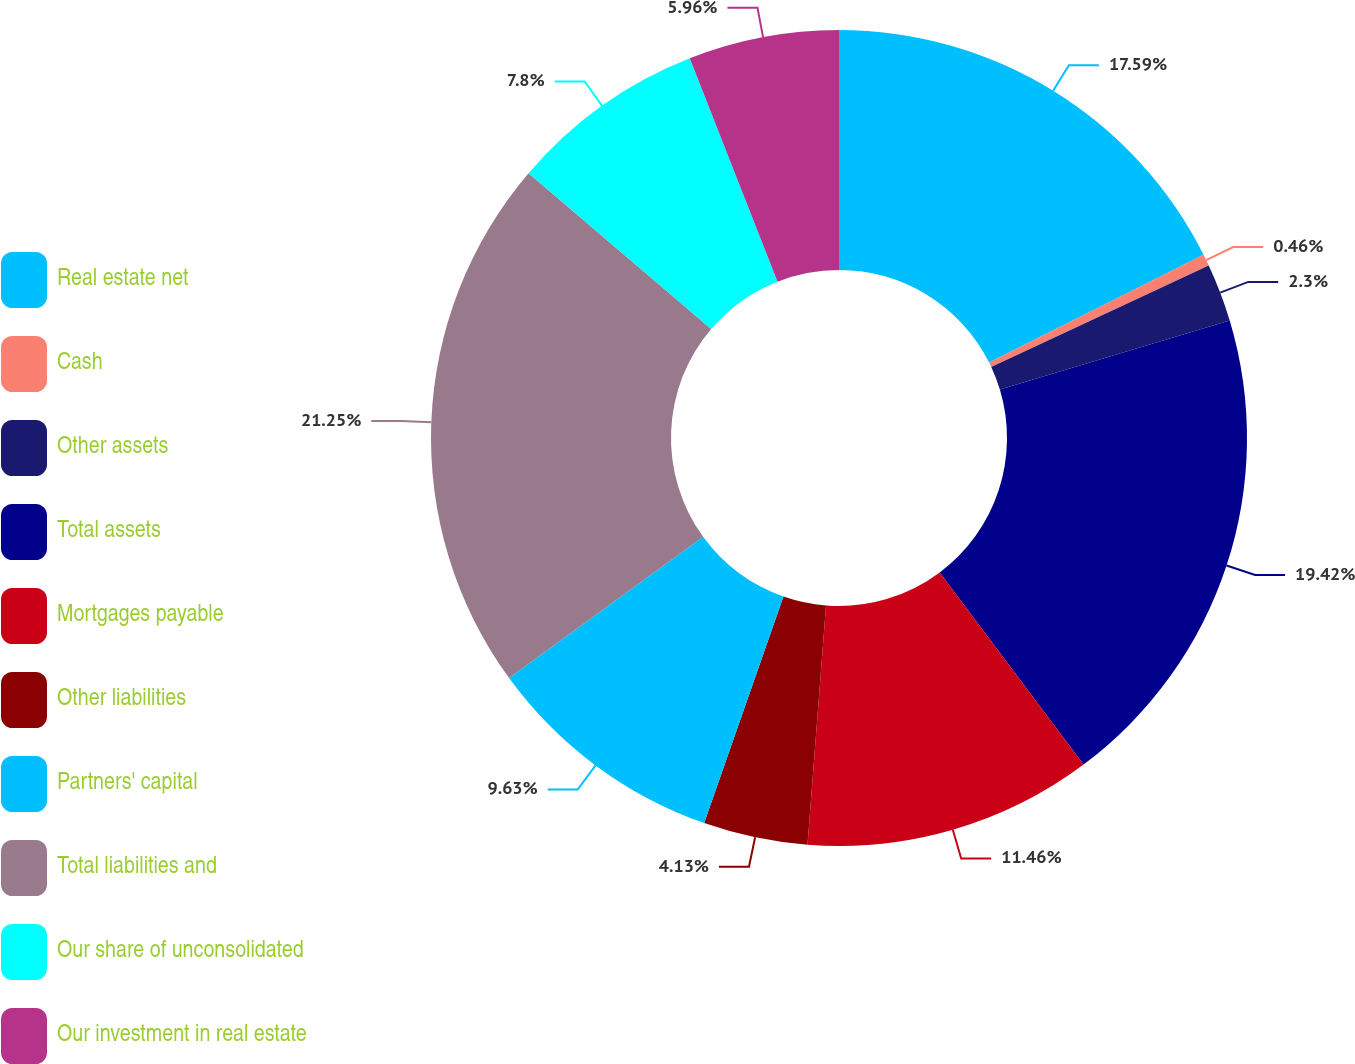<chart> <loc_0><loc_0><loc_500><loc_500><pie_chart><fcel>Real estate net<fcel>Cash<fcel>Other assets<fcel>Total assets<fcel>Mortgages payable<fcel>Other liabilities<fcel>Partners' capital<fcel>Total liabilities and<fcel>Our share of unconsolidated<fcel>Our investment in real estate<nl><fcel>17.59%<fcel>0.46%<fcel>2.3%<fcel>19.42%<fcel>11.46%<fcel>4.13%<fcel>9.63%<fcel>21.25%<fcel>7.8%<fcel>5.96%<nl></chart> 